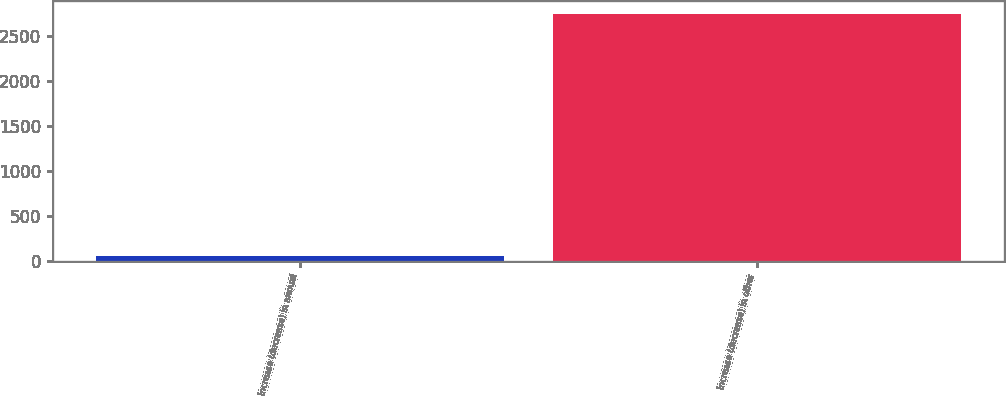Convert chart. <chart><loc_0><loc_0><loc_500><loc_500><bar_chart><fcel>Increase (decrease) in annual<fcel>Increase (decrease) in other<nl><fcel>59<fcel>2748<nl></chart> 